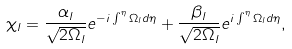<formula> <loc_0><loc_0><loc_500><loc_500>\chi _ { l } = \frac { \alpha _ { l } } { \sqrt { 2 \Omega _ { l } } } e ^ { - i \int ^ { \eta } \Omega _ { l } d \eta } + \frac { \beta _ { l } } { \sqrt { 2 \Omega _ { l } } } e ^ { i \int ^ { \eta } \Omega _ { l } d \eta } ,</formula> 